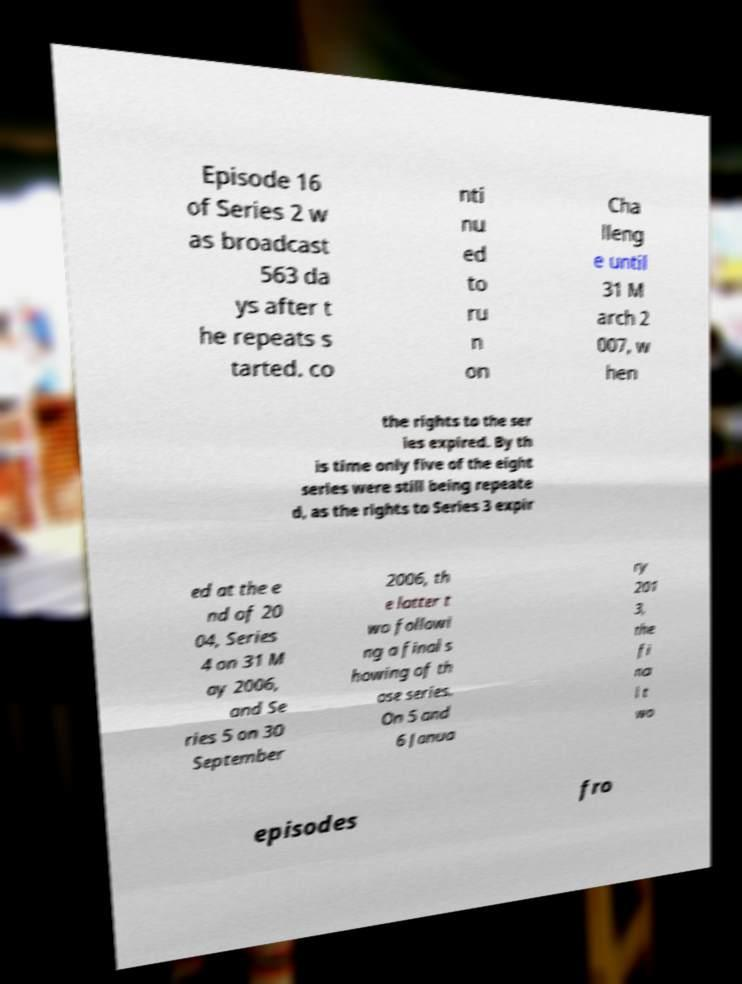For documentation purposes, I need the text within this image transcribed. Could you provide that? Episode 16 of Series 2 w as broadcast 563 da ys after t he repeats s tarted. co nti nu ed to ru n on Cha lleng e until 31 M arch 2 007, w hen the rights to the ser ies expired. By th is time only five of the eight series were still being repeate d, as the rights to Series 3 expir ed at the e nd of 20 04, Series 4 on 31 M ay 2006, and Se ries 5 on 30 September 2006, th e latter t wo followi ng a final s howing of th ose series. On 5 and 6 Janua ry 201 3, the fi na l t wo episodes fro 